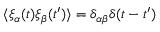<formula> <loc_0><loc_0><loc_500><loc_500>\langle \xi _ { \alpha } ( t ) \xi _ { \beta } ( t ^ { \prime } ) \rangle = \delta _ { \alpha \beta } \delta ( t - t ^ { \prime } )</formula> 